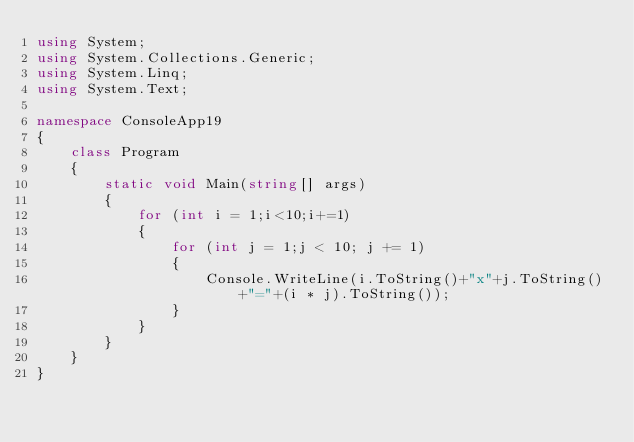<code> <loc_0><loc_0><loc_500><loc_500><_C#_>using System;
using System.Collections.Generic;
using System.Linq;
using System.Text;

namespace ConsoleApp19
{
    class Program
    {
        static void Main(string[] args)
        {
            for (int i = 1;i<10;i+=1)
            {
                for (int j = 1;j < 10; j += 1)
                {
                    Console.WriteLine(i.ToString()+"x"+j.ToString()+"="+(i * j).ToString());
                }
            }
        }
    }
}

</code> 